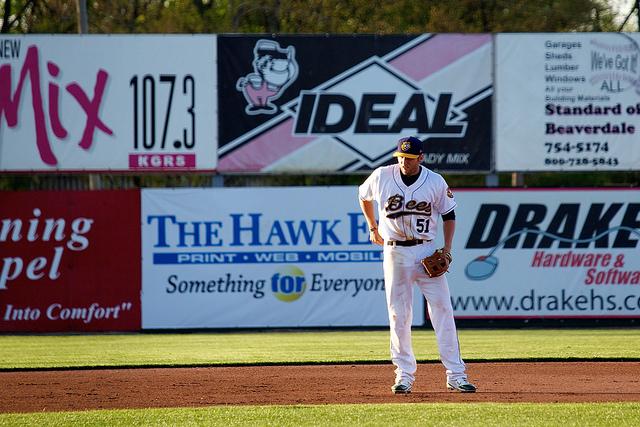What number is on the pitcher's jersey?
Be succinct. 51. Is he tired?
Give a very brief answer. Yes. Is the team on the field the Bears?
Answer briefly. Yes. 